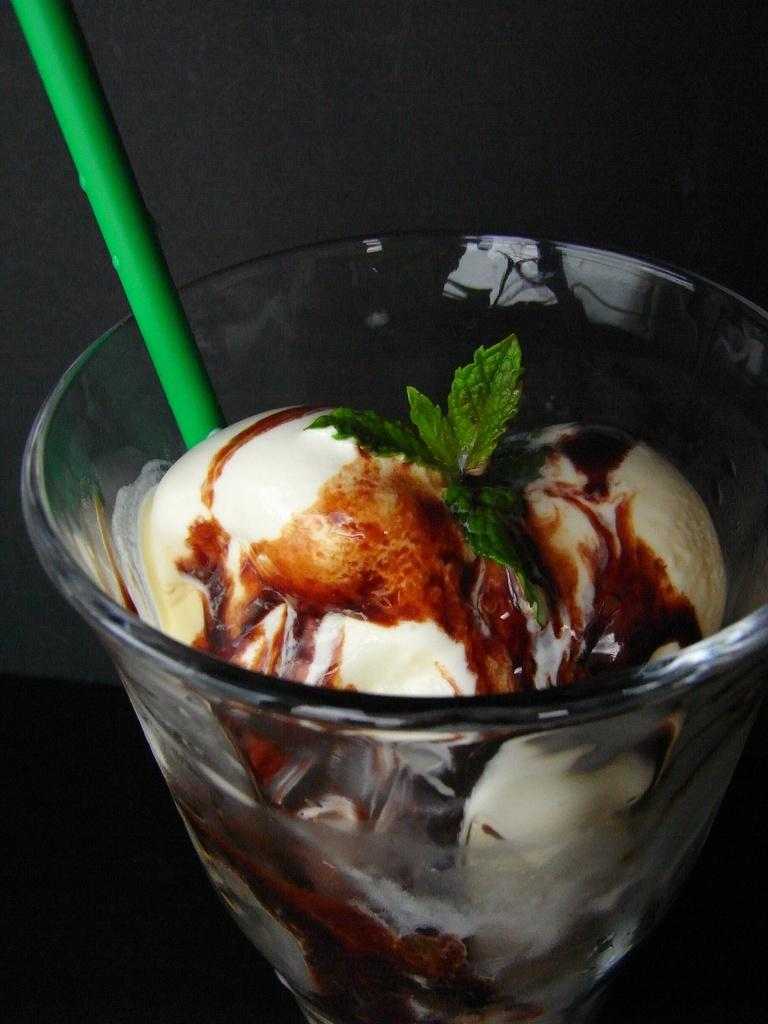What is in the glass that is visible in the image? There is a glass with ice cream in the image. What is placed on top of the ice cream? There are mint leaves on the ice cream. What can be used to drink from the glass? There is a straw in the glass. How would you describe the lighting in the image? The background of the image is dark. What color is the dress worn by the daughter in the image? There is no daughter or dress present in the image. 